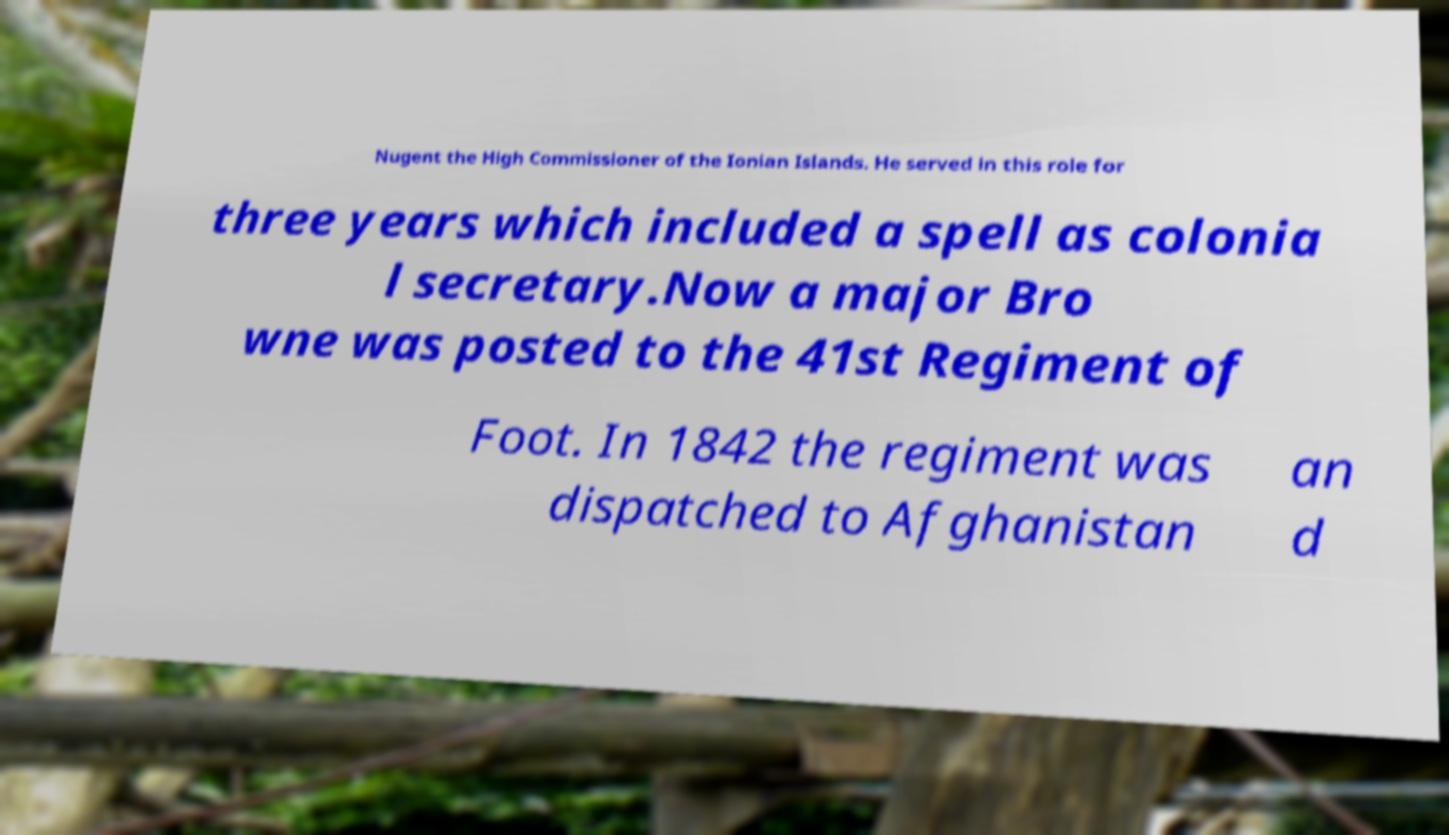For documentation purposes, I need the text within this image transcribed. Could you provide that? Nugent the High Commissioner of the Ionian Islands. He served in this role for three years which included a spell as colonia l secretary.Now a major Bro wne was posted to the 41st Regiment of Foot. In 1842 the regiment was dispatched to Afghanistan an d 